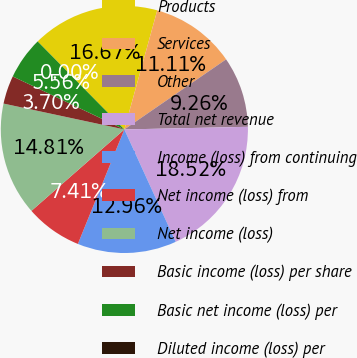Convert chart to OTSL. <chart><loc_0><loc_0><loc_500><loc_500><pie_chart><fcel>Products<fcel>Services<fcel>Other<fcel>Total net revenue<fcel>Income (loss) from continuing<fcel>Net income (loss) from<fcel>Net income (loss)<fcel>Basic income (loss) per share<fcel>Basic net income (loss) per<fcel>Diluted income (loss) per<nl><fcel>16.67%<fcel>11.11%<fcel>9.26%<fcel>18.52%<fcel>12.96%<fcel>7.41%<fcel>14.81%<fcel>3.7%<fcel>5.56%<fcel>0.0%<nl></chart> 